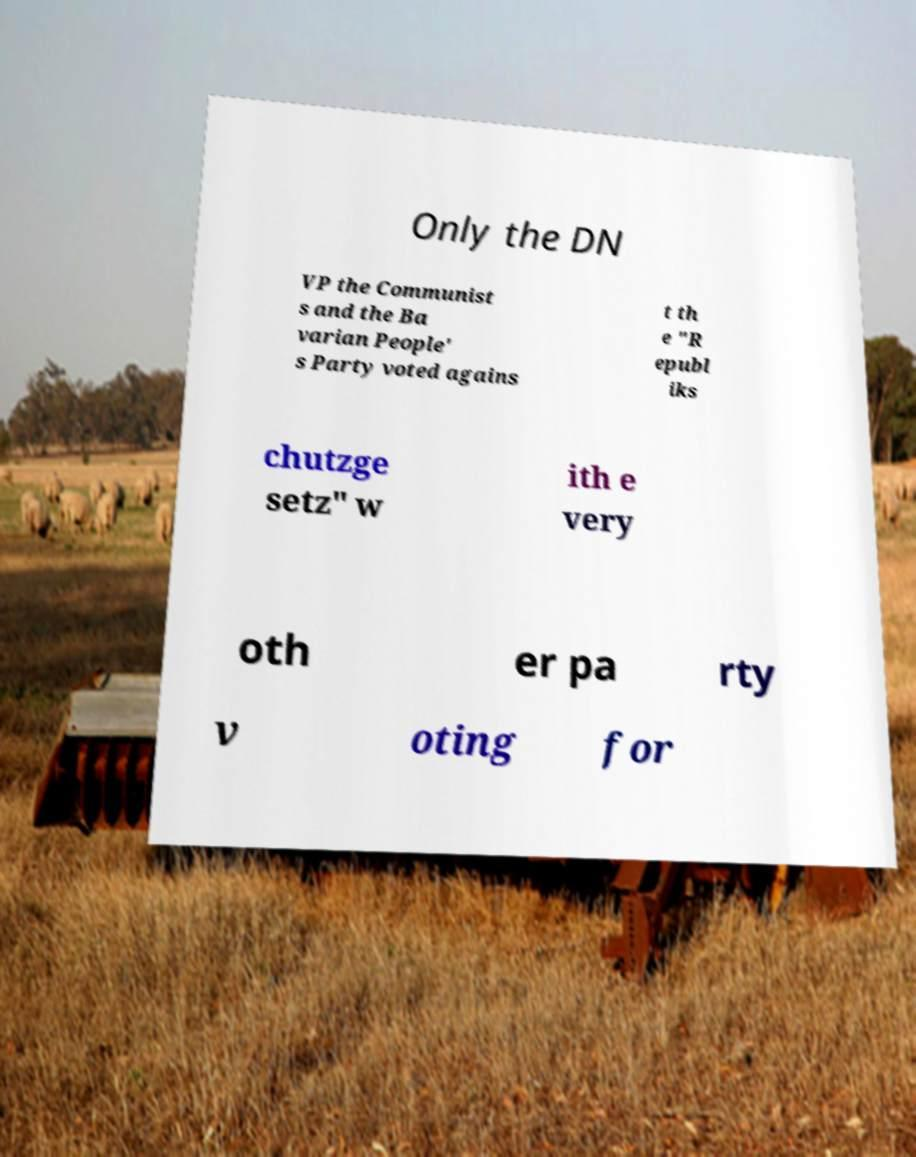Could you assist in decoding the text presented in this image and type it out clearly? Only the DN VP the Communist s and the Ba varian People' s Party voted agains t th e "R epubl iks chutzge setz" w ith e very oth er pa rty v oting for 